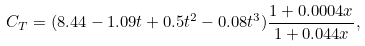<formula> <loc_0><loc_0><loc_500><loc_500>C _ { T } = ( 8 . 4 4 - 1 . 0 9 t + 0 . 5 t ^ { 2 } - 0 . 0 8 t ^ { 3 } ) \frac { 1 + 0 . 0 0 0 4 x } { 1 + 0 . 0 4 4 x } ,</formula> 